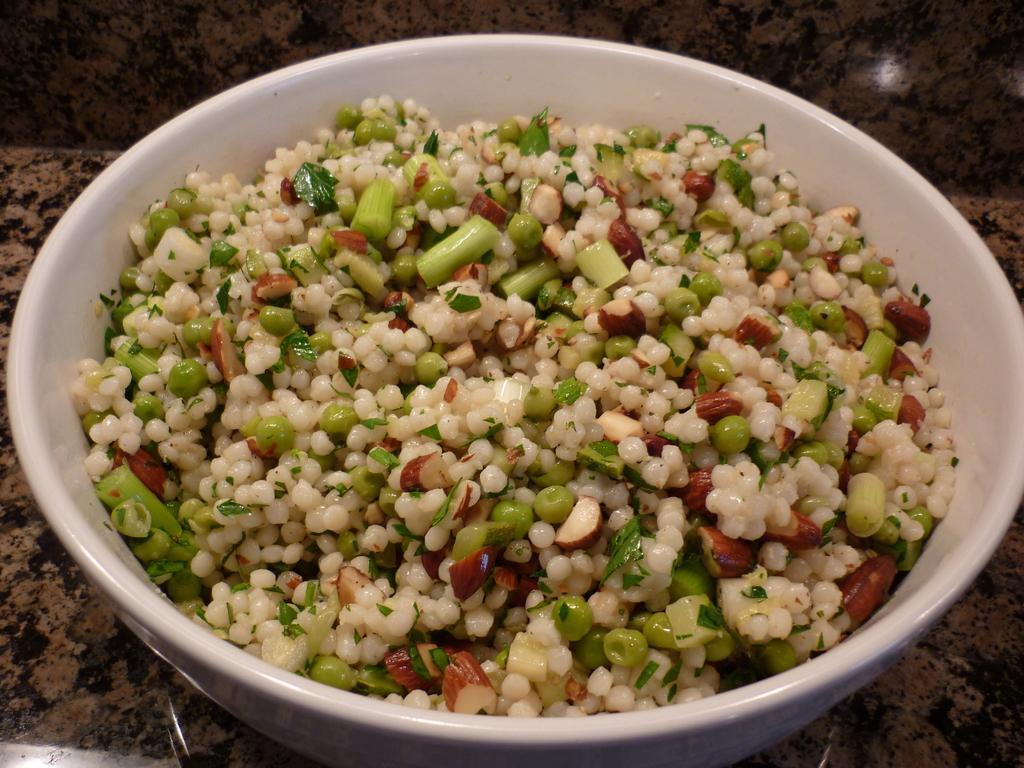Please provide a concise description of this image. In this image on a bowl there is some food. The bowl is placed on the counter. 